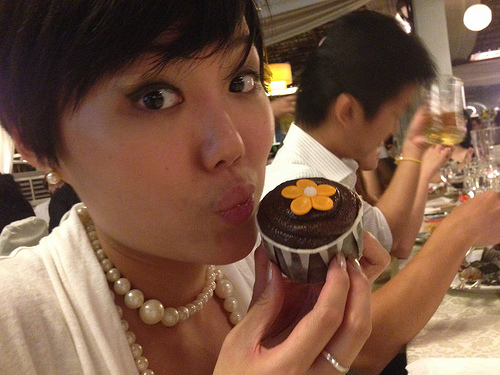Are there mobile phones or screens in this scene? No, there are no mobile phones or screens visible in this scene. 